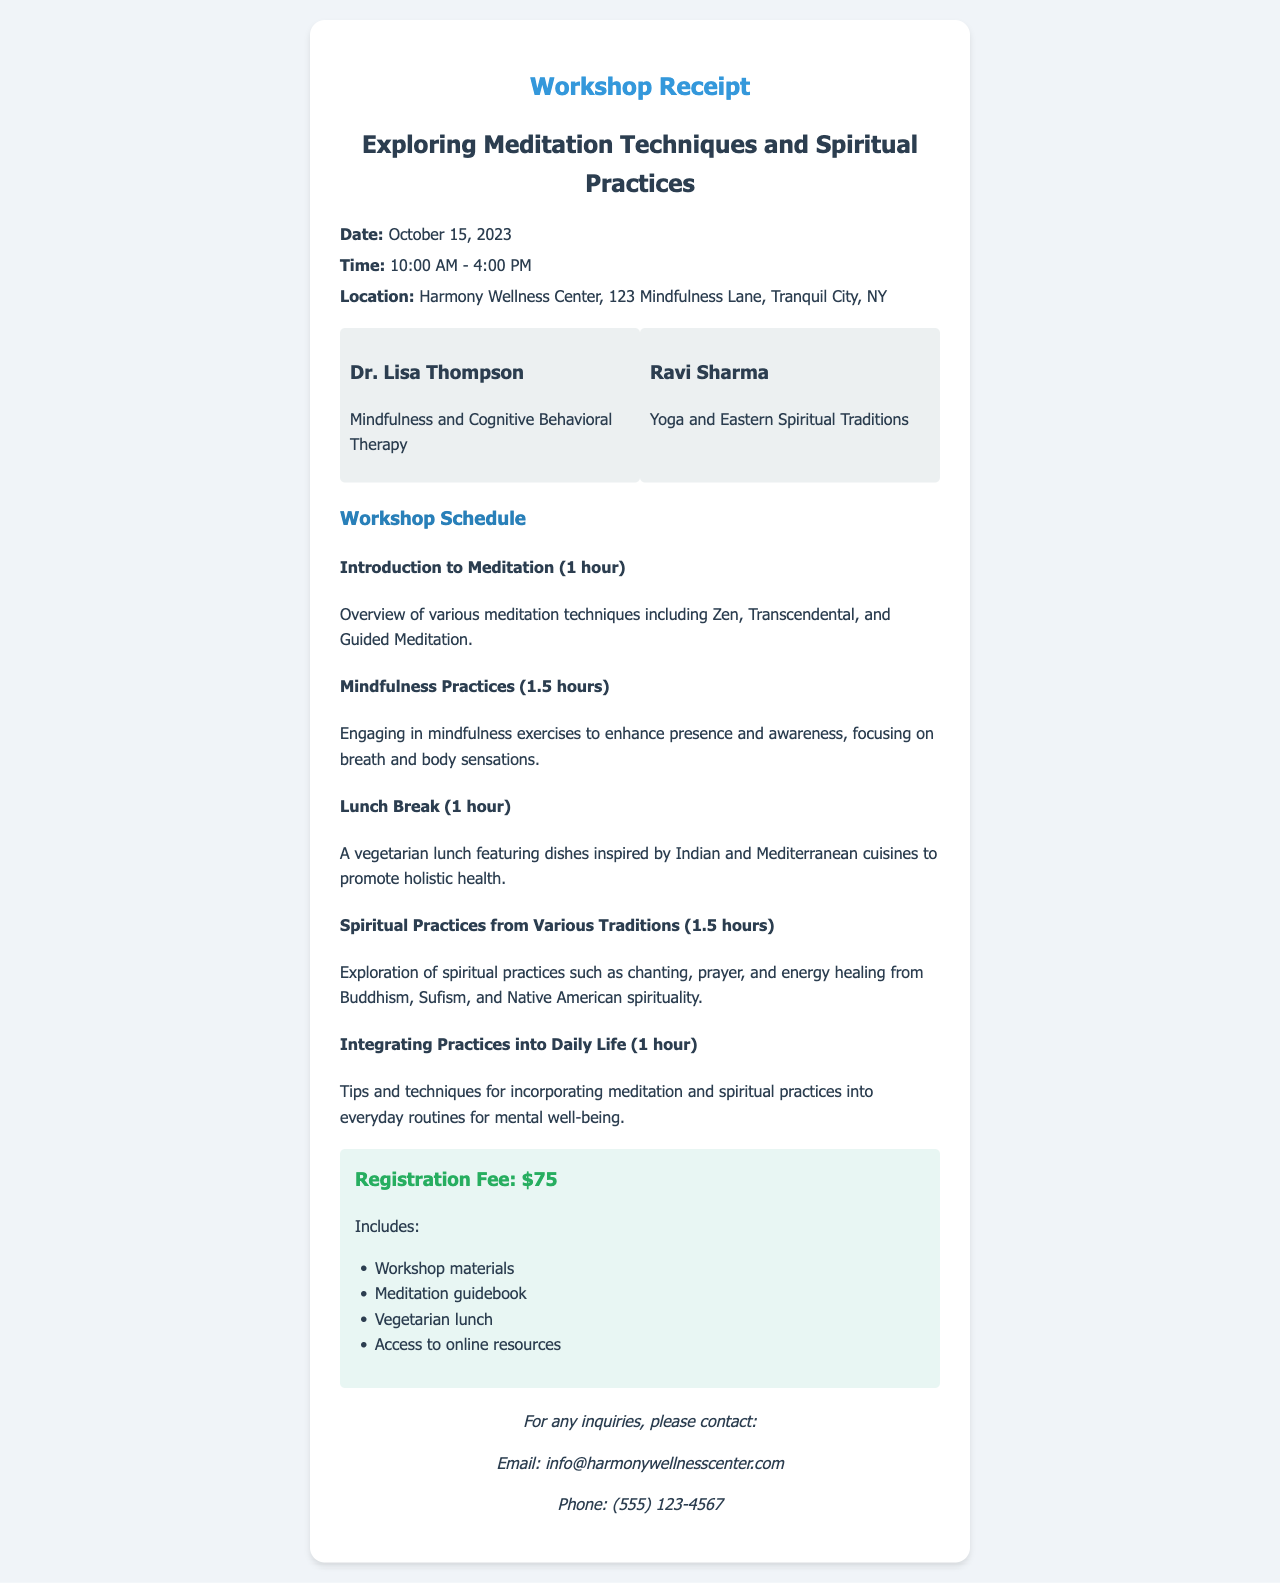What is the date of the workshop? The date of the workshop is provided in the details section of the receipt.
Answer: October 15, 2023 What is the registration fee? The registration fee is specified in the fee section of the receipt.
Answer: $75 Who is one of the facilitators? The names of the facilitators are listed in the facilitators section of the receipt.
Answer: Dr. Lisa Thompson What type of lunch is provided? The details about the lunch are included in the workshop schedule section.
Answer: Vegetarian How long is the session on mindfulness practices? The duration of the mindfulness practices session is mentioned in the schedule section of the receipt.
Answer: 1.5 hours What is the location of the workshop? The location is noted in the details section of the receipt.
Answer: Harmony Wellness Center, 123 Mindfulness Lane, Tranquil City, NY What will participants receive as part of the registration? The items included with the registration fee are listed in the fee section of the receipt.
Answer: Workshop materials What is the topic of the last session? The topic of the last session is indicated in the workshop schedule section of the receipt.
Answer: Integrating Practices into Daily Life How many hours does the entire workshop last? The total duration can be calculated by summing the durations provided for each session outlined in the workshop schedule.
Answer: 6 hours 